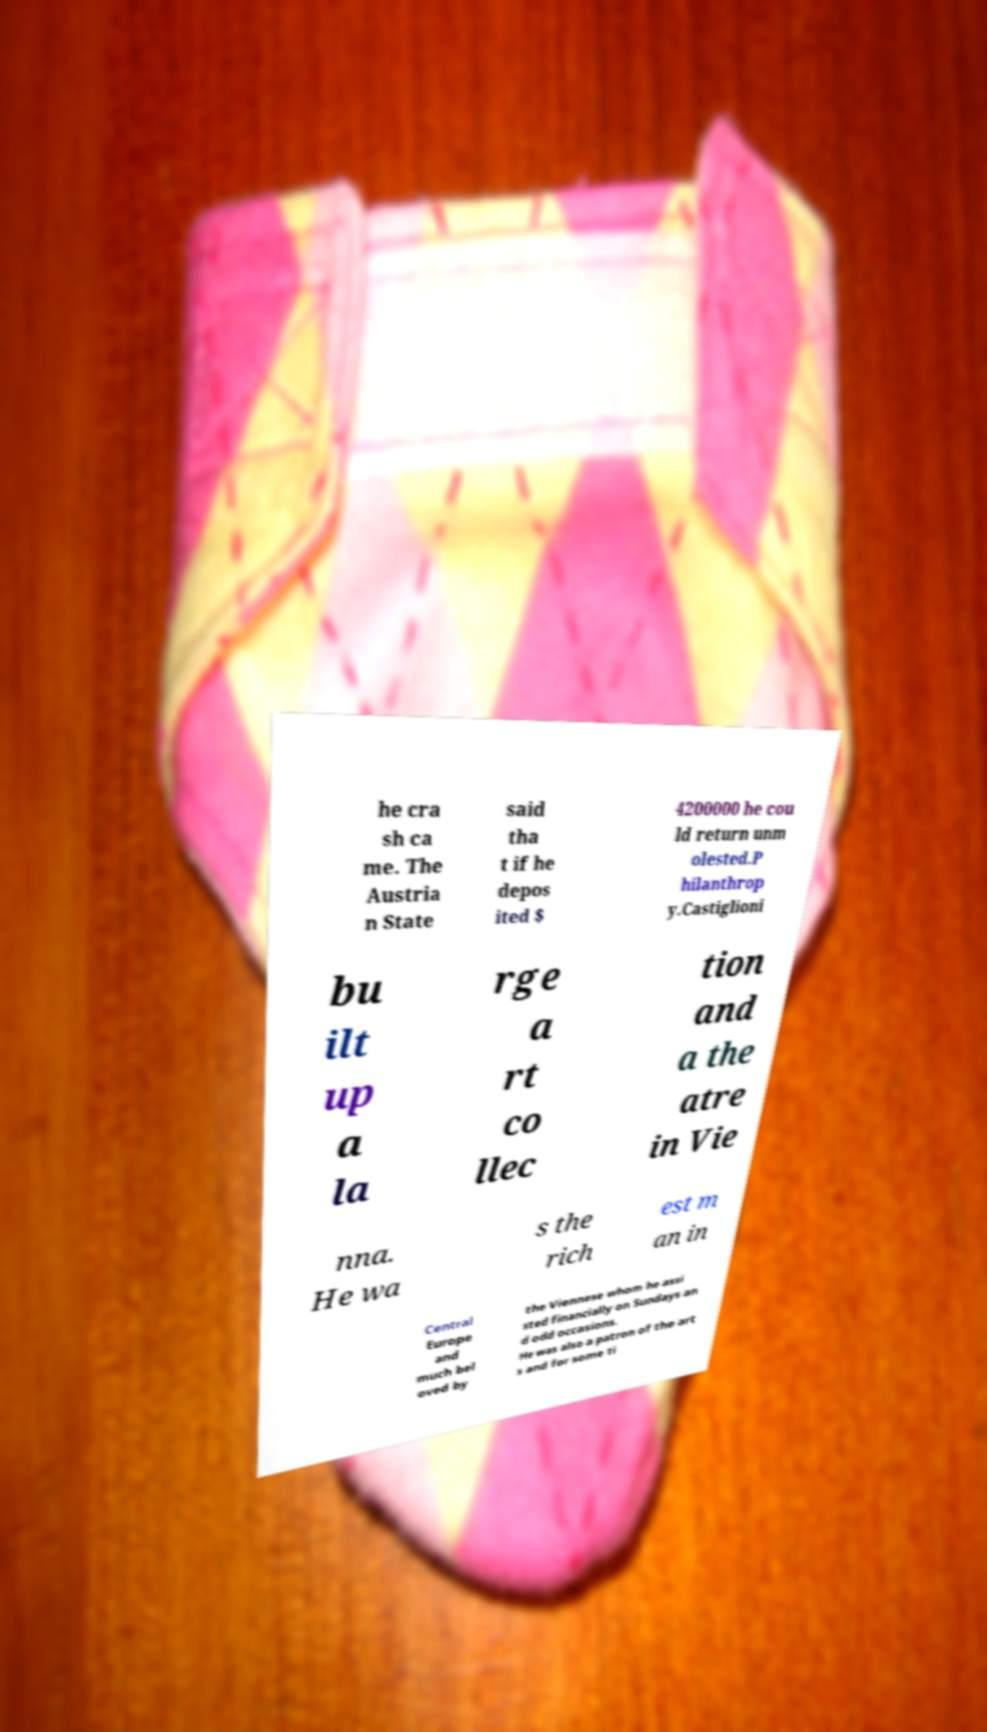Can you read and provide the text displayed in the image?This photo seems to have some interesting text. Can you extract and type it out for me? he cra sh ca me. The Austria n State said tha t if he depos ited $ 4200000 he cou ld return unm olested.P hilanthrop y.Castiglioni bu ilt up a la rge a rt co llec tion and a the atre in Vie nna. He wa s the rich est m an in Central Europe and much bel oved by the Viennese whom he assi sted financially on Sundays an d odd occasions. He was also a patron of the art s and for some ti 